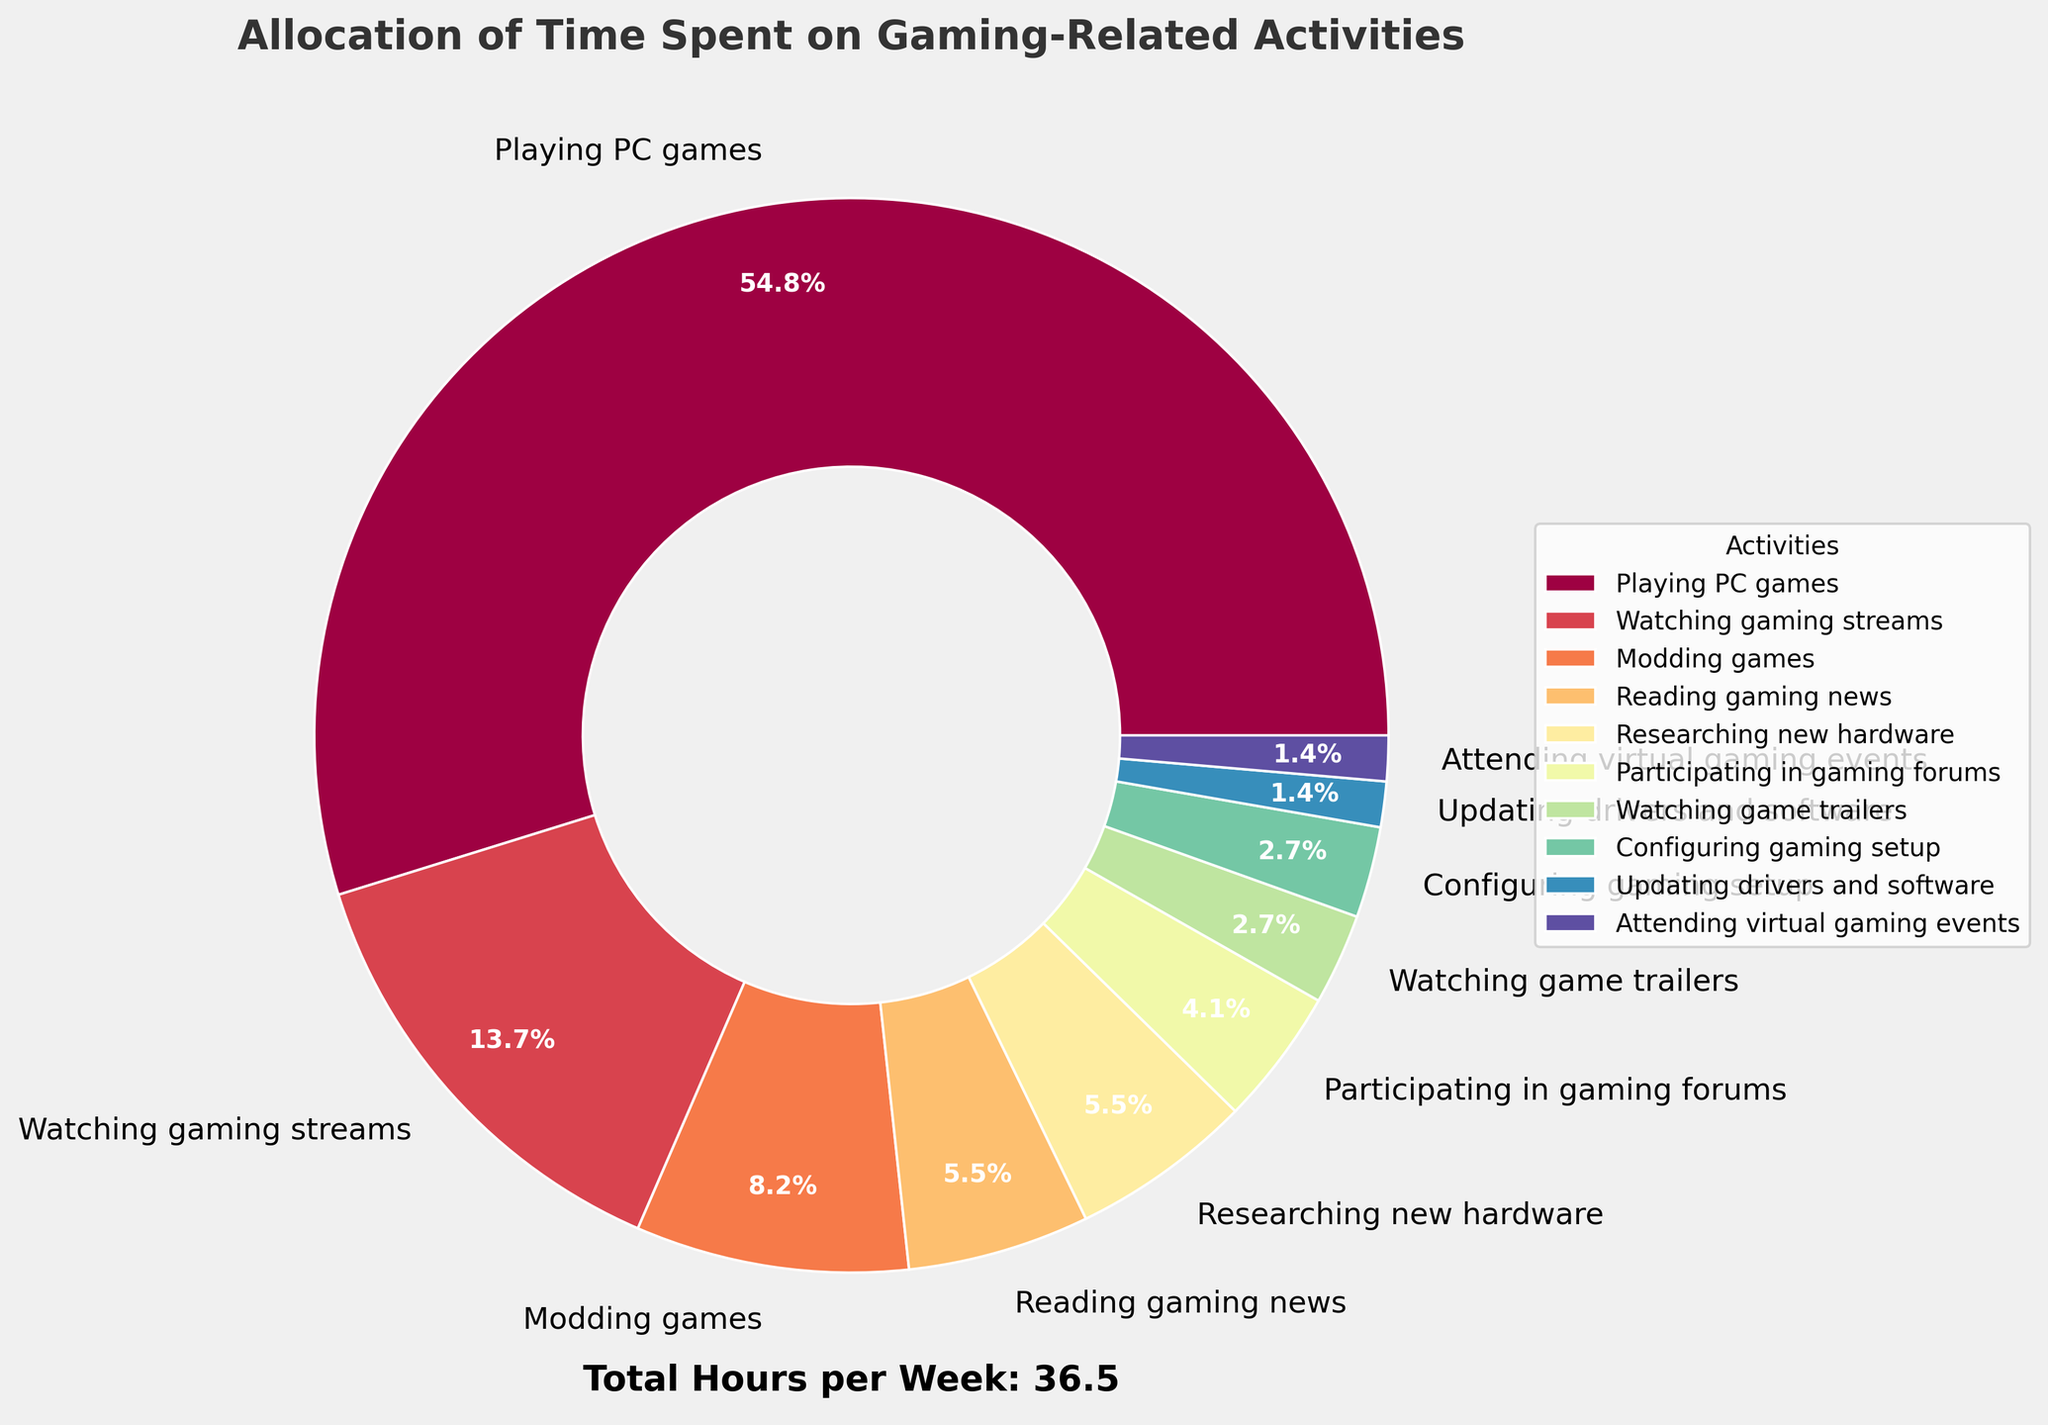Which activity takes up the most time? The activity with the largest proportional wedge in the pie chart is "Playing PC games." This can be determined visually by identifying the largest section of the pie.
Answer: Playing PC games Which two activities together take almost the same amount of time as watching gaming streams? Watching gaming streams takes 5 hours per week. Modding games (3 hours) and reading gaming news (2 hours) together sum up to the same amount of time (3 + 2 = 5 hours).
Answer: Modding games and reading gaming news What percentage of time is spent on activities other than playing PC games? From the pie chart, we see that playing PC games accounts for 20 hours out of a total of 36.5 hours. To find the percentage of time spent on other activities: (36.5 - 20) / 36.5 * 100 = 45.2%.
Answer: 45.2% How does the time spent on researching new hardware compare to the time spent configuring the gaming setup? Visually, the time spent on both researching new hardware and configuring the gaming setup is represented equally in the chart, with both taking up 2 and 1 hours respectively.
Answer: 2 times more Is more time spent updating drivers and software or attending virtual gaming events? Visually on the pie chart, both updating drivers and software and attending virtual gaming events take up equal amounts of time (0.5 hours) as shown by their similarly sized wedges.
Answer: Equal Which activity has the smallest wedge in the pie chart? Examining the smallest wedge in the pie chart, the activity is "Attending virtual gaming events."
Answer: Attending virtual gaming events What is the combined proportion of time spent on watching gaming streams and reading gaming news? Watching gaming streams takes 5 hours per week and reading gaming news takes 2 hours per week. Together they make up 5 + 2 = 7 hours. To find the proportion: 7 / 36.5 * 100 ≈ 19.2%.
Answer: 19.2% How many times more is the time spent playing PC games compared to updating drivers and software? Playing PC games takes 20 hours per week while updating drivers and software takes 0.5 hours. The ratio is 20 / 0.5 = 40 times more.
Answer: 40 times What visual cue is used to differentiate between the activities in the pie chart? The pie chart uses different colors to represent different activities, making it easy to visually differentiate between them.
Answer: Colors Which three activities together contribute to exactly half of the total gaming-related activities in hours per week? The total hours per week for all activities are 36.5. Half of this is 18.25 hours. Playing PC games (20 hours alone exceeds half). The closest combination without exceeding is watching gaming streams (5h), modding games (3h), and reading gaming news (2h) + researching new hardware (2h) + participating in gaming forums (1.5h) + watching game trailers (1h) + configuring gaming setup (1h) = 15.5 hours. Adding "configuring gaming setup (1h)" totals to 17 hours which is still less so it's not exact but the closest.
Answer: Watching gaming streams, Modding games, Reading gaming news 